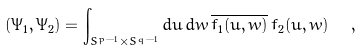Convert formula to latex. <formula><loc_0><loc_0><loc_500><loc_500>( \Psi _ { 1 } , \Psi _ { 2 } ) = \int _ { S ^ { p - 1 } \times S ^ { q - 1 } } d u \, d w \, \overline { f _ { 1 } ( u , w ) } \, f _ { 2 } ( u , w ) \ \ ,</formula> 